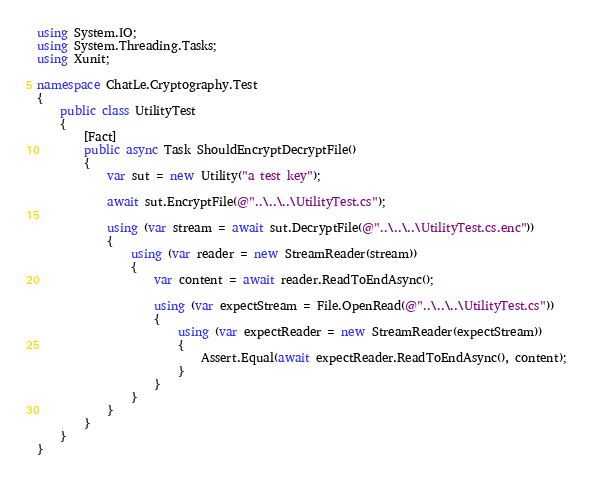<code> <loc_0><loc_0><loc_500><loc_500><_C#_>using System.IO;
using System.Threading.Tasks;
using Xunit;

namespace ChatLe.Cryptography.Test
{
    public class UtilityTest
    {
        [Fact]
        public async Task ShouldEncryptDecryptFile()
        {
            var sut = new Utility("a test key");

            await sut.EncryptFile(@"..\..\..\UtilityTest.cs");

            using (var stream = await sut.DecryptFile(@"..\..\..\UtilityTest.cs.enc"))
            {
                using (var reader = new StreamReader(stream))
                {
                    var content = await reader.ReadToEndAsync();

                    using (var expectStream = File.OpenRead(@"..\..\..\UtilityTest.cs"))
                    {
                        using (var expectReader = new StreamReader(expectStream))
                        {
                            Assert.Equal(await expectReader.ReadToEndAsync(), content);
                        }
                    }
                }
            }
        }
    }
}
</code> 